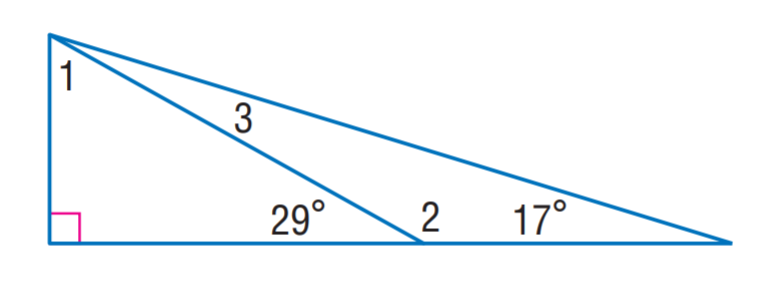Question: Find m \angle 2.
Choices:
A. 12
B. 61
C. 151
D. 163
Answer with the letter. Answer: C Question: Find m \angle 3.
Choices:
A. 12
B. 17
C. 61
D. 151
Answer with the letter. Answer: A 